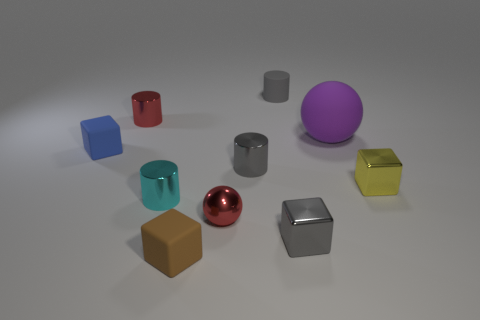There is a cylinder that is the same color as the tiny sphere; what material is it?
Provide a short and direct response. Metal. There is a tiny gray thing that is made of the same material as the purple sphere; what shape is it?
Keep it short and to the point. Cylinder. Are there more tiny red metal balls that are right of the big purple matte thing than tiny gray rubber cylinders in front of the small blue rubber cube?
Offer a very short reply. No. What number of objects are either gray rubber things or small blue blocks?
Provide a short and direct response. 2. How many other objects are the same color as the rubber cylinder?
Provide a succinct answer. 2. What shape is the blue object that is the same size as the gray block?
Offer a very short reply. Cube. There is a metal thing right of the large rubber ball; what is its color?
Your answer should be very brief. Yellow. What number of things are metallic cylinders left of the cyan metallic object or tiny metal things that are behind the tiny blue block?
Offer a very short reply. 1. Is the brown object the same size as the gray block?
Give a very brief answer. Yes. How many blocks are either brown things or small yellow shiny things?
Your response must be concise. 2. 